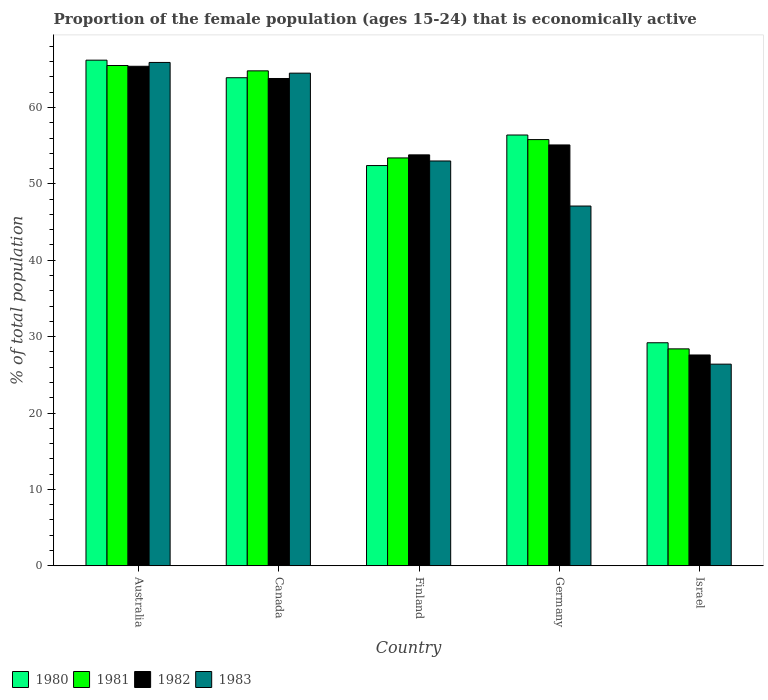How many different coloured bars are there?
Make the answer very short. 4. How many bars are there on the 3rd tick from the right?
Give a very brief answer. 4. What is the proportion of the female population that is economically active in 1982 in Germany?
Make the answer very short. 55.1. Across all countries, what is the maximum proportion of the female population that is economically active in 1982?
Provide a short and direct response. 65.4. Across all countries, what is the minimum proportion of the female population that is economically active in 1980?
Ensure brevity in your answer.  29.2. In which country was the proportion of the female population that is economically active in 1981 minimum?
Offer a terse response. Israel. What is the total proportion of the female population that is economically active in 1981 in the graph?
Make the answer very short. 267.9. What is the difference between the proportion of the female population that is economically active in 1981 in Australia and that in Finland?
Keep it short and to the point. 12.1. What is the difference between the proportion of the female population that is economically active in 1982 in Germany and the proportion of the female population that is economically active in 1983 in Finland?
Provide a short and direct response. 2.1. What is the average proportion of the female population that is economically active in 1983 per country?
Offer a very short reply. 51.38. What is the difference between the proportion of the female population that is economically active of/in 1983 and proportion of the female population that is economically active of/in 1981 in Finland?
Give a very brief answer. -0.4. In how many countries, is the proportion of the female population that is economically active in 1982 greater than 26 %?
Make the answer very short. 5. What is the ratio of the proportion of the female population that is economically active in 1983 in Germany to that in Israel?
Offer a very short reply. 1.78. What is the difference between the highest and the second highest proportion of the female population that is economically active in 1983?
Offer a terse response. -1.4. What is the difference between the highest and the lowest proportion of the female population that is economically active in 1981?
Provide a short and direct response. 37.1. Is the sum of the proportion of the female population that is economically active in 1981 in Canada and Israel greater than the maximum proportion of the female population that is economically active in 1983 across all countries?
Your answer should be very brief. Yes. Is it the case that in every country, the sum of the proportion of the female population that is economically active in 1982 and proportion of the female population that is economically active in 1980 is greater than the sum of proportion of the female population that is economically active in 1983 and proportion of the female population that is economically active in 1981?
Your answer should be very brief. No. What does the 3rd bar from the right in Germany represents?
Keep it short and to the point. 1981. How many bars are there?
Ensure brevity in your answer.  20. Are all the bars in the graph horizontal?
Your answer should be compact. No. How many countries are there in the graph?
Offer a terse response. 5. Where does the legend appear in the graph?
Make the answer very short. Bottom left. How many legend labels are there?
Your answer should be compact. 4. What is the title of the graph?
Ensure brevity in your answer.  Proportion of the female population (ages 15-24) that is economically active. What is the label or title of the Y-axis?
Provide a short and direct response. % of total population. What is the % of total population in 1980 in Australia?
Offer a very short reply. 66.2. What is the % of total population of 1981 in Australia?
Your response must be concise. 65.5. What is the % of total population of 1982 in Australia?
Give a very brief answer. 65.4. What is the % of total population of 1983 in Australia?
Make the answer very short. 65.9. What is the % of total population of 1980 in Canada?
Your answer should be very brief. 63.9. What is the % of total population in 1981 in Canada?
Your answer should be compact. 64.8. What is the % of total population of 1982 in Canada?
Give a very brief answer. 63.8. What is the % of total population in 1983 in Canada?
Your answer should be compact. 64.5. What is the % of total population of 1980 in Finland?
Ensure brevity in your answer.  52.4. What is the % of total population of 1981 in Finland?
Keep it short and to the point. 53.4. What is the % of total population of 1982 in Finland?
Make the answer very short. 53.8. What is the % of total population in 1983 in Finland?
Keep it short and to the point. 53. What is the % of total population in 1980 in Germany?
Your response must be concise. 56.4. What is the % of total population of 1981 in Germany?
Make the answer very short. 55.8. What is the % of total population in 1982 in Germany?
Your answer should be compact. 55.1. What is the % of total population of 1983 in Germany?
Your answer should be compact. 47.1. What is the % of total population of 1980 in Israel?
Offer a very short reply. 29.2. What is the % of total population of 1981 in Israel?
Your response must be concise. 28.4. What is the % of total population of 1982 in Israel?
Your answer should be compact. 27.6. What is the % of total population of 1983 in Israel?
Make the answer very short. 26.4. Across all countries, what is the maximum % of total population of 1980?
Keep it short and to the point. 66.2. Across all countries, what is the maximum % of total population in 1981?
Provide a succinct answer. 65.5. Across all countries, what is the maximum % of total population of 1982?
Give a very brief answer. 65.4. Across all countries, what is the maximum % of total population of 1983?
Provide a short and direct response. 65.9. Across all countries, what is the minimum % of total population of 1980?
Give a very brief answer. 29.2. Across all countries, what is the minimum % of total population in 1981?
Make the answer very short. 28.4. Across all countries, what is the minimum % of total population of 1982?
Provide a succinct answer. 27.6. Across all countries, what is the minimum % of total population of 1983?
Keep it short and to the point. 26.4. What is the total % of total population in 1980 in the graph?
Give a very brief answer. 268.1. What is the total % of total population in 1981 in the graph?
Offer a very short reply. 267.9. What is the total % of total population in 1982 in the graph?
Make the answer very short. 265.7. What is the total % of total population in 1983 in the graph?
Give a very brief answer. 256.9. What is the difference between the % of total population of 1980 in Australia and that in Canada?
Your answer should be very brief. 2.3. What is the difference between the % of total population of 1982 in Australia and that in Germany?
Provide a short and direct response. 10.3. What is the difference between the % of total population of 1983 in Australia and that in Germany?
Keep it short and to the point. 18.8. What is the difference between the % of total population in 1981 in Australia and that in Israel?
Provide a short and direct response. 37.1. What is the difference between the % of total population in 1982 in Australia and that in Israel?
Make the answer very short. 37.8. What is the difference between the % of total population of 1983 in Australia and that in Israel?
Give a very brief answer. 39.5. What is the difference between the % of total population of 1981 in Canada and that in Finland?
Your response must be concise. 11.4. What is the difference between the % of total population of 1982 in Canada and that in Finland?
Provide a short and direct response. 10. What is the difference between the % of total population in 1980 in Canada and that in Germany?
Your response must be concise. 7.5. What is the difference between the % of total population in 1980 in Canada and that in Israel?
Your answer should be very brief. 34.7. What is the difference between the % of total population of 1981 in Canada and that in Israel?
Provide a succinct answer. 36.4. What is the difference between the % of total population in 1982 in Canada and that in Israel?
Make the answer very short. 36.2. What is the difference between the % of total population in 1983 in Canada and that in Israel?
Offer a terse response. 38.1. What is the difference between the % of total population of 1980 in Finland and that in Germany?
Provide a succinct answer. -4. What is the difference between the % of total population of 1981 in Finland and that in Germany?
Your answer should be very brief. -2.4. What is the difference between the % of total population in 1982 in Finland and that in Germany?
Your answer should be very brief. -1.3. What is the difference between the % of total population of 1980 in Finland and that in Israel?
Your response must be concise. 23.2. What is the difference between the % of total population of 1982 in Finland and that in Israel?
Ensure brevity in your answer.  26.2. What is the difference between the % of total population of 1983 in Finland and that in Israel?
Your response must be concise. 26.6. What is the difference between the % of total population of 1980 in Germany and that in Israel?
Provide a short and direct response. 27.2. What is the difference between the % of total population of 1981 in Germany and that in Israel?
Ensure brevity in your answer.  27.4. What is the difference between the % of total population of 1982 in Germany and that in Israel?
Give a very brief answer. 27.5. What is the difference between the % of total population of 1983 in Germany and that in Israel?
Your response must be concise. 20.7. What is the difference between the % of total population of 1980 in Australia and the % of total population of 1982 in Canada?
Provide a succinct answer. 2.4. What is the difference between the % of total population of 1980 in Australia and the % of total population of 1983 in Canada?
Ensure brevity in your answer.  1.7. What is the difference between the % of total population of 1981 in Australia and the % of total population of 1983 in Canada?
Your answer should be very brief. 1. What is the difference between the % of total population of 1982 in Australia and the % of total population of 1983 in Canada?
Your response must be concise. 0.9. What is the difference between the % of total population in 1980 in Australia and the % of total population in 1981 in Finland?
Provide a short and direct response. 12.8. What is the difference between the % of total population in 1981 in Australia and the % of total population in 1983 in Finland?
Offer a terse response. 12.5. What is the difference between the % of total population of 1982 in Australia and the % of total population of 1983 in Finland?
Make the answer very short. 12.4. What is the difference between the % of total population of 1980 in Australia and the % of total population of 1982 in Germany?
Your response must be concise. 11.1. What is the difference between the % of total population in 1980 in Australia and the % of total population in 1983 in Germany?
Provide a short and direct response. 19.1. What is the difference between the % of total population of 1981 in Australia and the % of total population of 1982 in Germany?
Provide a short and direct response. 10.4. What is the difference between the % of total population in 1982 in Australia and the % of total population in 1983 in Germany?
Offer a terse response. 18.3. What is the difference between the % of total population in 1980 in Australia and the % of total population in 1981 in Israel?
Your answer should be compact. 37.8. What is the difference between the % of total population of 1980 in Australia and the % of total population of 1982 in Israel?
Provide a short and direct response. 38.6. What is the difference between the % of total population in 1980 in Australia and the % of total population in 1983 in Israel?
Offer a very short reply. 39.8. What is the difference between the % of total population in 1981 in Australia and the % of total population in 1982 in Israel?
Provide a short and direct response. 37.9. What is the difference between the % of total population of 1981 in Australia and the % of total population of 1983 in Israel?
Your response must be concise. 39.1. What is the difference between the % of total population in 1982 in Australia and the % of total population in 1983 in Israel?
Offer a terse response. 39. What is the difference between the % of total population in 1980 in Canada and the % of total population in 1981 in Finland?
Keep it short and to the point. 10.5. What is the difference between the % of total population in 1980 in Canada and the % of total population in 1982 in Finland?
Keep it short and to the point. 10.1. What is the difference between the % of total population in 1982 in Canada and the % of total population in 1983 in Finland?
Provide a short and direct response. 10.8. What is the difference between the % of total population of 1980 in Canada and the % of total population of 1983 in Germany?
Provide a succinct answer. 16.8. What is the difference between the % of total population of 1980 in Canada and the % of total population of 1981 in Israel?
Provide a short and direct response. 35.5. What is the difference between the % of total population of 1980 in Canada and the % of total population of 1982 in Israel?
Provide a short and direct response. 36.3. What is the difference between the % of total population of 1980 in Canada and the % of total population of 1983 in Israel?
Offer a very short reply. 37.5. What is the difference between the % of total population of 1981 in Canada and the % of total population of 1982 in Israel?
Offer a terse response. 37.2. What is the difference between the % of total population in 1981 in Canada and the % of total population in 1983 in Israel?
Ensure brevity in your answer.  38.4. What is the difference between the % of total population of 1982 in Canada and the % of total population of 1983 in Israel?
Provide a succinct answer. 37.4. What is the difference between the % of total population of 1980 in Finland and the % of total population of 1981 in Germany?
Keep it short and to the point. -3.4. What is the difference between the % of total population of 1981 in Finland and the % of total population of 1983 in Germany?
Provide a short and direct response. 6.3. What is the difference between the % of total population in 1980 in Finland and the % of total population in 1982 in Israel?
Offer a very short reply. 24.8. What is the difference between the % of total population in 1981 in Finland and the % of total population in 1982 in Israel?
Offer a very short reply. 25.8. What is the difference between the % of total population in 1981 in Finland and the % of total population in 1983 in Israel?
Make the answer very short. 27. What is the difference between the % of total population of 1982 in Finland and the % of total population of 1983 in Israel?
Your answer should be very brief. 27.4. What is the difference between the % of total population in 1980 in Germany and the % of total population in 1982 in Israel?
Make the answer very short. 28.8. What is the difference between the % of total population of 1981 in Germany and the % of total population of 1982 in Israel?
Keep it short and to the point. 28.2. What is the difference between the % of total population of 1981 in Germany and the % of total population of 1983 in Israel?
Keep it short and to the point. 29.4. What is the difference between the % of total population of 1982 in Germany and the % of total population of 1983 in Israel?
Offer a very short reply. 28.7. What is the average % of total population in 1980 per country?
Provide a succinct answer. 53.62. What is the average % of total population of 1981 per country?
Offer a terse response. 53.58. What is the average % of total population in 1982 per country?
Offer a terse response. 53.14. What is the average % of total population of 1983 per country?
Provide a short and direct response. 51.38. What is the difference between the % of total population in 1980 and % of total population in 1981 in Australia?
Give a very brief answer. 0.7. What is the difference between the % of total population in 1981 and % of total population in 1982 in Australia?
Give a very brief answer. 0.1. What is the difference between the % of total population of 1981 and % of total population of 1983 in Australia?
Your response must be concise. -0.4. What is the difference between the % of total population in 1980 and % of total population in 1982 in Canada?
Offer a terse response. 0.1. What is the difference between the % of total population of 1981 and % of total population of 1982 in Canada?
Keep it short and to the point. 1. What is the difference between the % of total population of 1980 and % of total population of 1981 in Finland?
Keep it short and to the point. -1. What is the difference between the % of total population in 1981 and % of total population in 1983 in Finland?
Provide a succinct answer. 0.4. What is the difference between the % of total population in 1982 and % of total population in 1983 in Finland?
Your response must be concise. 0.8. What is the difference between the % of total population in 1981 and % of total population in 1982 in Germany?
Provide a succinct answer. 0.7. What is the difference between the % of total population in 1981 and % of total population in 1983 in Germany?
Keep it short and to the point. 8.7. What is the difference between the % of total population of 1980 and % of total population of 1981 in Israel?
Provide a succinct answer. 0.8. What is the difference between the % of total population of 1980 and % of total population of 1982 in Israel?
Offer a terse response. 1.6. What is the difference between the % of total population in 1981 and % of total population in 1982 in Israel?
Your answer should be very brief. 0.8. What is the ratio of the % of total population of 1980 in Australia to that in Canada?
Your response must be concise. 1.04. What is the ratio of the % of total population of 1981 in Australia to that in Canada?
Ensure brevity in your answer.  1.01. What is the ratio of the % of total population in 1982 in Australia to that in Canada?
Keep it short and to the point. 1.03. What is the ratio of the % of total population in 1983 in Australia to that in Canada?
Make the answer very short. 1.02. What is the ratio of the % of total population in 1980 in Australia to that in Finland?
Give a very brief answer. 1.26. What is the ratio of the % of total population of 1981 in Australia to that in Finland?
Ensure brevity in your answer.  1.23. What is the ratio of the % of total population of 1982 in Australia to that in Finland?
Your response must be concise. 1.22. What is the ratio of the % of total population of 1983 in Australia to that in Finland?
Your answer should be compact. 1.24. What is the ratio of the % of total population of 1980 in Australia to that in Germany?
Make the answer very short. 1.17. What is the ratio of the % of total population of 1981 in Australia to that in Germany?
Your answer should be very brief. 1.17. What is the ratio of the % of total population in 1982 in Australia to that in Germany?
Make the answer very short. 1.19. What is the ratio of the % of total population of 1983 in Australia to that in Germany?
Provide a short and direct response. 1.4. What is the ratio of the % of total population of 1980 in Australia to that in Israel?
Your answer should be very brief. 2.27. What is the ratio of the % of total population in 1981 in Australia to that in Israel?
Make the answer very short. 2.31. What is the ratio of the % of total population in 1982 in Australia to that in Israel?
Provide a succinct answer. 2.37. What is the ratio of the % of total population in 1983 in Australia to that in Israel?
Keep it short and to the point. 2.5. What is the ratio of the % of total population in 1980 in Canada to that in Finland?
Provide a short and direct response. 1.22. What is the ratio of the % of total population of 1981 in Canada to that in Finland?
Keep it short and to the point. 1.21. What is the ratio of the % of total population in 1982 in Canada to that in Finland?
Offer a very short reply. 1.19. What is the ratio of the % of total population in 1983 in Canada to that in Finland?
Keep it short and to the point. 1.22. What is the ratio of the % of total population in 1980 in Canada to that in Germany?
Ensure brevity in your answer.  1.13. What is the ratio of the % of total population of 1981 in Canada to that in Germany?
Your answer should be compact. 1.16. What is the ratio of the % of total population of 1982 in Canada to that in Germany?
Give a very brief answer. 1.16. What is the ratio of the % of total population of 1983 in Canada to that in Germany?
Your answer should be very brief. 1.37. What is the ratio of the % of total population in 1980 in Canada to that in Israel?
Ensure brevity in your answer.  2.19. What is the ratio of the % of total population in 1981 in Canada to that in Israel?
Offer a very short reply. 2.28. What is the ratio of the % of total population of 1982 in Canada to that in Israel?
Give a very brief answer. 2.31. What is the ratio of the % of total population of 1983 in Canada to that in Israel?
Give a very brief answer. 2.44. What is the ratio of the % of total population of 1980 in Finland to that in Germany?
Your answer should be very brief. 0.93. What is the ratio of the % of total population of 1982 in Finland to that in Germany?
Offer a terse response. 0.98. What is the ratio of the % of total population in 1983 in Finland to that in Germany?
Offer a very short reply. 1.13. What is the ratio of the % of total population in 1980 in Finland to that in Israel?
Your answer should be very brief. 1.79. What is the ratio of the % of total population in 1981 in Finland to that in Israel?
Your answer should be very brief. 1.88. What is the ratio of the % of total population in 1982 in Finland to that in Israel?
Your answer should be very brief. 1.95. What is the ratio of the % of total population in 1983 in Finland to that in Israel?
Your answer should be very brief. 2.01. What is the ratio of the % of total population in 1980 in Germany to that in Israel?
Make the answer very short. 1.93. What is the ratio of the % of total population of 1981 in Germany to that in Israel?
Make the answer very short. 1.96. What is the ratio of the % of total population of 1982 in Germany to that in Israel?
Provide a short and direct response. 2. What is the ratio of the % of total population of 1983 in Germany to that in Israel?
Your answer should be very brief. 1.78. What is the difference between the highest and the second highest % of total population in 1980?
Offer a terse response. 2.3. What is the difference between the highest and the second highest % of total population in 1981?
Ensure brevity in your answer.  0.7. What is the difference between the highest and the second highest % of total population of 1983?
Provide a short and direct response. 1.4. What is the difference between the highest and the lowest % of total population of 1980?
Provide a short and direct response. 37. What is the difference between the highest and the lowest % of total population of 1981?
Provide a succinct answer. 37.1. What is the difference between the highest and the lowest % of total population in 1982?
Ensure brevity in your answer.  37.8. What is the difference between the highest and the lowest % of total population of 1983?
Offer a very short reply. 39.5. 